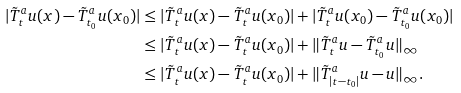<formula> <loc_0><loc_0><loc_500><loc_500>| \tilde { T } ^ { a } _ { t } u ( x ) - \tilde { T } ^ { a } _ { t _ { 0 } } u ( x _ { 0 } ) | & \leq | \tilde { T } ^ { a } _ { t } u ( x ) - \tilde { T } ^ { a } _ { t } u ( x _ { 0 } ) | + | \tilde { T } ^ { a } _ { t } u ( x _ { 0 } ) - \tilde { T } ^ { a } _ { t _ { 0 } } u ( x _ { 0 } ) | \\ & \leq | \tilde { T } ^ { a } _ { t } u ( x ) - \tilde { T } ^ { a } _ { t } u ( x _ { 0 } ) | + \| \tilde { T } ^ { a } _ { t } u - \tilde { T } ^ { a } _ { t _ { 0 } } u \| _ { \infty } \\ & \leq | \tilde { T } ^ { a } _ { t } u ( x ) - \tilde { T } ^ { a } _ { t } u ( x _ { 0 } ) | + \| \tilde { T } ^ { a } _ { | t - t _ { 0 } | } u - u \| _ { \infty } .</formula> 